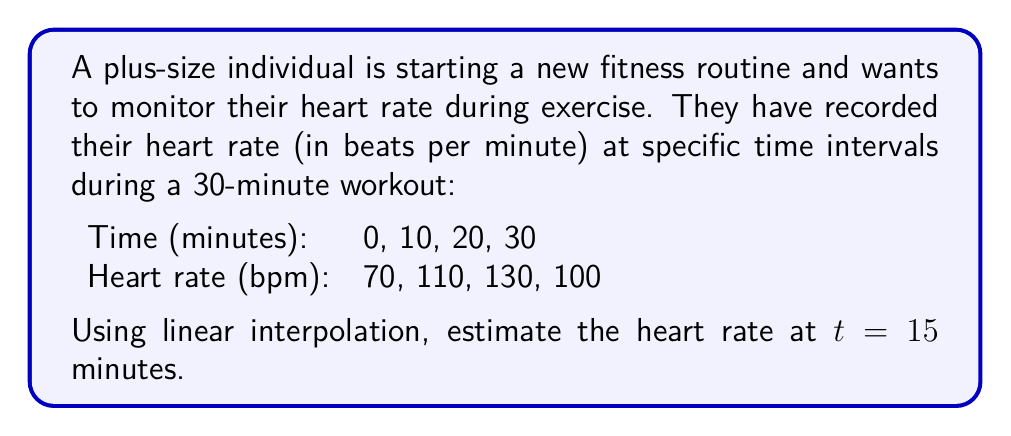Could you help me with this problem? To solve this problem using linear interpolation, we'll follow these steps:

1) Identify the two known data points that surround t = 15 minutes:
   (t₁, y₁) = (10, 110) and (t₂, y₂) = (20, 130)

2) The linear interpolation formula is:

   $$y = y_1 + \frac{y_2 - y_1}{t_2 - t_1}(t - t_1)$$

   Where:
   - y is the interpolated value (heart rate) we're solving for
   - t is the time we're interpolating at (15 minutes)

3) Substitute the known values into the formula:

   $$y = 110 + \frac{130 - 110}{20 - 10}(15 - 10)$$

4) Simplify:
   $$y = 110 + \frac{20}{10}(5)$$
   $$y = 110 + 2(5)$$
   $$y = 110 + 10$$
   $$y = 120$$

Therefore, the estimated heart rate at t = 15 minutes is 120 bpm.
Answer: 120 bpm 